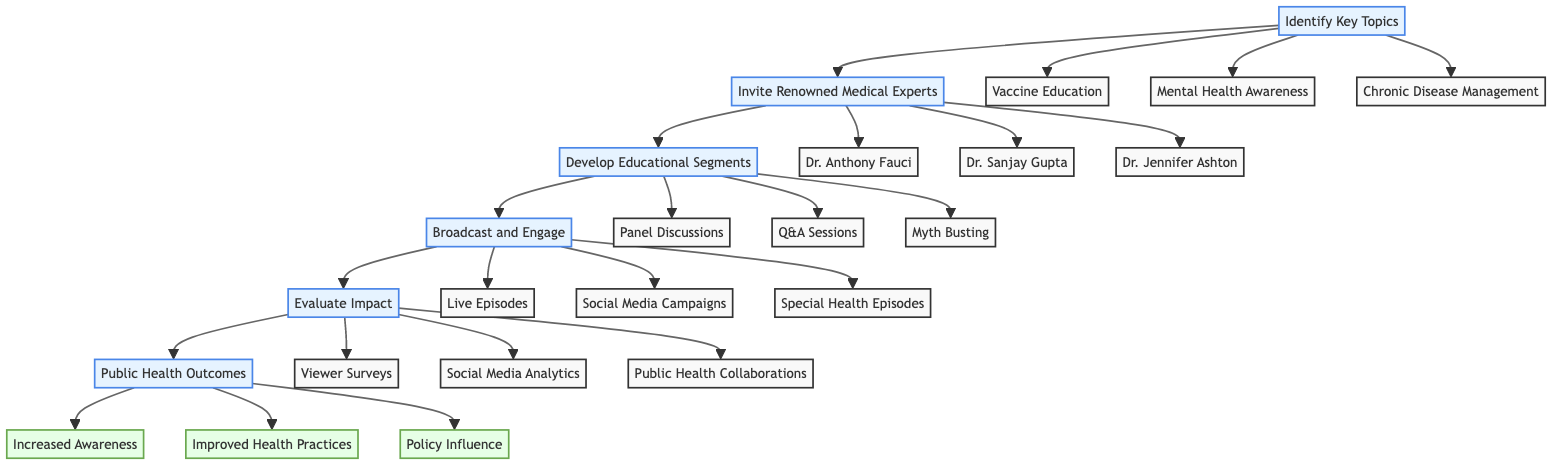What are the key topics identified in the pathway? The diagram lists three key topics that serve as foundational subjects for discussion. They are: Vaccine Education, Mental Health Awareness, and Chronic Disease Management.
Answer: Vaccine Education, Mental Health Awareness, Chronic Disease Management How many renowned medical experts are invited? The diagram outlines that three renowned medical experts are invited to discuss public health education contributions.
Answer: 3 What type of segments are developed in the pathway? The pathway specifies three types of educational segments that are developed: Panel Discussions, Q&A Sessions, and Myth Busting.
Answer: Panel Discussions, Q&A Sessions, Myth Busting Which step comes after "Broadcast and Engage"? Following the "Broadcast and Engage" step in the pathway, the next step focuses on evaluating the impact of the segments broadcasted.
Answer: Evaluate Impact What are some public health outcomes expected from this pathway? The diagram indicates three public health outcomes that are anticipated as a result of the efforts described: Increased Awareness, Improved Health Practices, and Policy Influence.
Answer: Increased Awareness, Improved Health Practices, Policy Influence Which medical expert specializes in infectious diseases? Among the invited medical experts, Dr. Anthony Fauci is identified as the one specializing in infectious diseases.
Answer: Dr. Anthony Fauci How do viewer surveys contribute to the pathway? Viewer surveys are part of the "Evaluate Impact" step, providing essential feedback about the segments' effectiveness and reach to the audience.
Answer: Evaluate Impact What kind of campaigns are included in the "Broadcast and Engage" step? This step incorporates interactive campaigns aimed at engaging the audience, specifically mentioning Social Media Campaigns among others.
Answer: Social Media Campaigns 